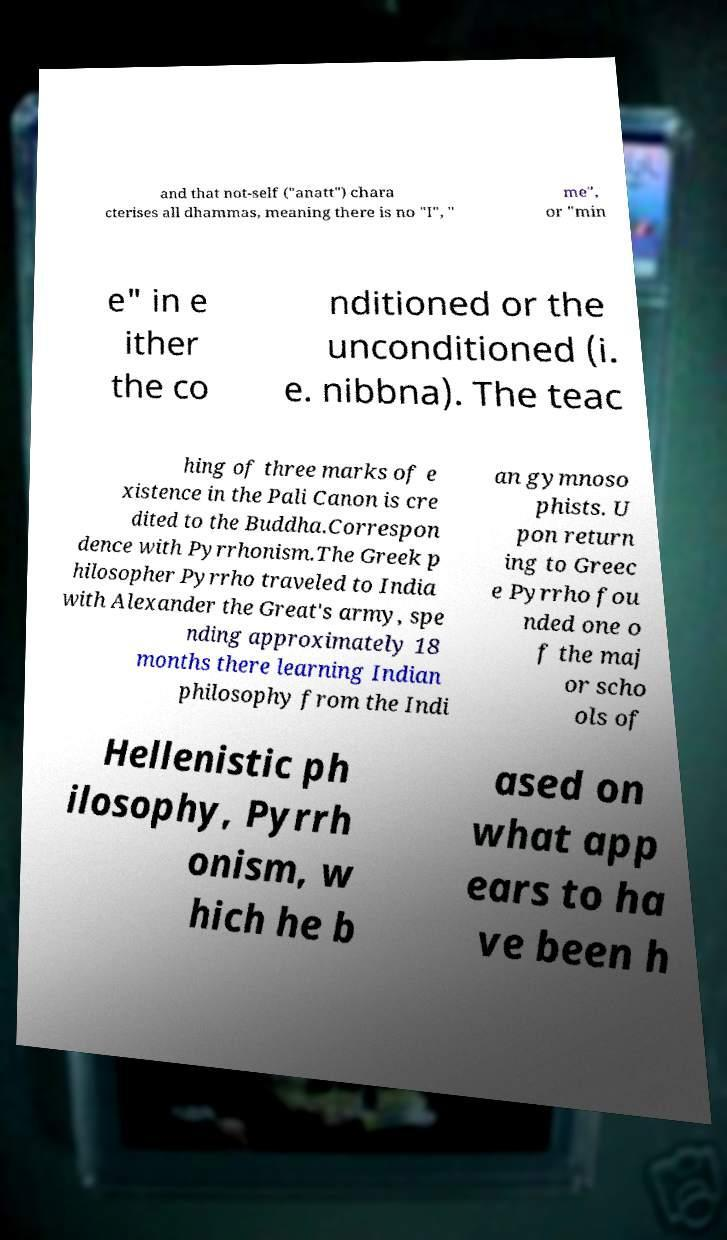For documentation purposes, I need the text within this image transcribed. Could you provide that? and that not-self ("anatt") chara cterises all dhammas, meaning there is no "I", " me", or "min e" in e ither the co nditioned or the unconditioned (i. e. nibbna). The teac hing of three marks of e xistence in the Pali Canon is cre dited to the Buddha.Correspon dence with Pyrrhonism.The Greek p hilosopher Pyrrho traveled to India with Alexander the Great's army, spe nding approximately 18 months there learning Indian philosophy from the Indi an gymnoso phists. U pon return ing to Greec e Pyrrho fou nded one o f the maj or scho ols of Hellenistic ph ilosophy, Pyrrh onism, w hich he b ased on what app ears to ha ve been h 